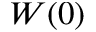Convert formula to latex. <formula><loc_0><loc_0><loc_500><loc_500>W ( 0 )</formula> 